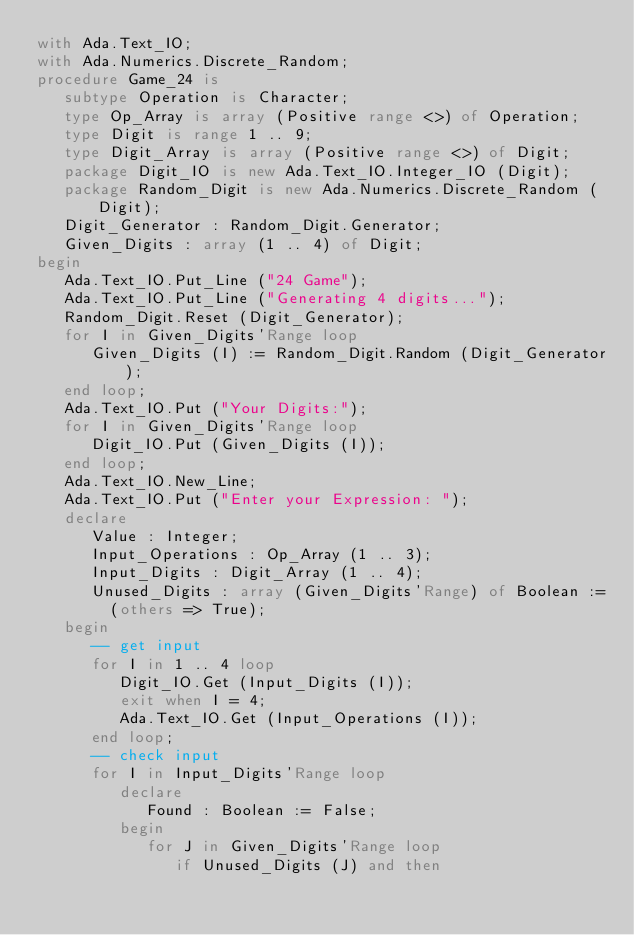<code> <loc_0><loc_0><loc_500><loc_500><_Ada_>with Ada.Text_IO;
with Ada.Numerics.Discrete_Random;
procedure Game_24 is
   subtype Operation is Character;
   type Op_Array is array (Positive range <>) of Operation;
   type Digit is range 1 .. 9;
   type Digit_Array is array (Positive range <>) of Digit;
   package Digit_IO is new Ada.Text_IO.Integer_IO (Digit);
   package Random_Digit is new Ada.Numerics.Discrete_Random (Digit);
   Digit_Generator : Random_Digit.Generator;
   Given_Digits : array (1 .. 4) of Digit;
begin
   Ada.Text_IO.Put_Line ("24 Game");
   Ada.Text_IO.Put_Line ("Generating 4 digits...");
   Random_Digit.Reset (Digit_Generator);
   for I in Given_Digits'Range loop
      Given_Digits (I) := Random_Digit.Random (Digit_Generator);
   end loop;
   Ada.Text_IO.Put ("Your Digits:");
   for I in Given_Digits'Range loop
      Digit_IO.Put (Given_Digits (I));
   end loop;
   Ada.Text_IO.New_Line;
   Ada.Text_IO.Put ("Enter your Expression: ");
   declare
      Value : Integer;
      Input_Operations : Op_Array (1 .. 3);
      Input_Digits : Digit_Array (1 .. 4);
      Unused_Digits : array (Given_Digits'Range) of Boolean :=
        (others => True);
   begin
      -- get input
      for I in 1 .. 4 loop
         Digit_IO.Get (Input_Digits (I));
         exit when I = 4;
         Ada.Text_IO.Get (Input_Operations (I));
      end loop;
      -- check input
      for I in Input_Digits'Range loop
         declare
            Found : Boolean := False;
         begin
            for J in Given_Digits'Range loop
               if Unused_Digits (J) and then</code> 